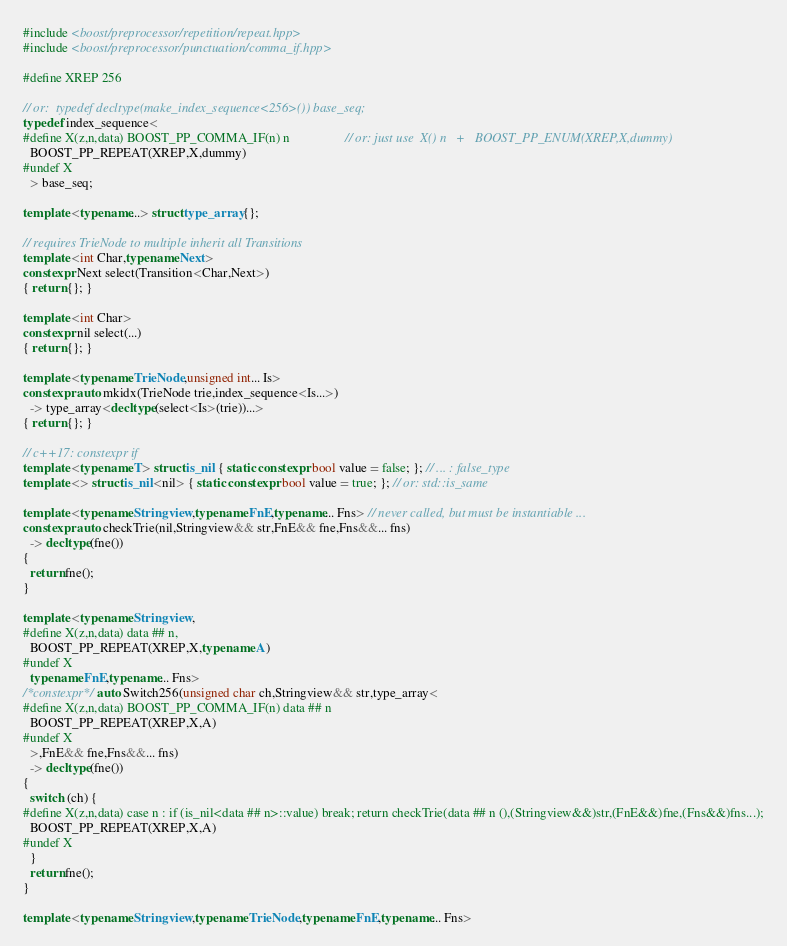<code> <loc_0><loc_0><loc_500><loc_500><_C++_>
#include <boost/preprocessor/repetition/repeat.hpp>
#include <boost/preprocessor/punctuation/comma_if.hpp>

#define XREP 256

// or:  typedef decltype(make_index_sequence<256>()) base_seq;
typedef index_sequence<
#define X(z,n,data) BOOST_PP_COMMA_IF(n) n                 // or: just use  X() n   +   BOOST_PP_ENUM(XREP,X,dummy)
  BOOST_PP_REPEAT(XREP,X,dummy)
#undef X
  > base_seq;

template <typename...> struct type_array {};

// requires TrieNode to multiple inherit all Transitions
template <int Char,typename Next>
constexpr Next select(Transition<Char,Next>)
{ return {}; }

template <int Char>
constexpr nil select(...)
{ return {}; }

template <typename TrieNode,unsigned int... Is>
constexpr auto mkidx(TrieNode trie,index_sequence<Is...>)
  -> type_array<decltype(select<Is>(trie))...>
{ return {}; }

// c++17: constexpr if
template <typename T> struct is_nil { static constexpr bool value = false; }; // ... : false_type
template <> struct is_nil<nil> { static constexpr bool value = true; }; // or: std::is_same

template <typename Stringview,typename FnE,typename... Fns> // never called, but must be instantiable ...
constexpr auto checkTrie(nil,Stringview&& str,FnE&& fne,Fns&&... fns)
  -> decltype(fne())
{
  return fne();
}

template <typename Stringview,
#define X(z,n,data) data ## n,
  BOOST_PP_REPEAT(XREP,X,typename A)
#undef X
  typename FnE,typename... Fns>
/*constexpr*/ auto Switch256(unsigned char ch,Stringview&& str,type_array<
#define X(z,n,data) BOOST_PP_COMMA_IF(n) data ## n
  BOOST_PP_REPEAT(XREP,X,A)
#undef X
  >,FnE&& fne,Fns&&... fns)
  -> decltype(fne())
{
  switch (ch) {
#define X(z,n,data) case n : if (is_nil<data ## n>::value) break; return checkTrie(data ## n (),(Stringview&&)str,(FnE&&)fne,(Fns&&)fns...);
  BOOST_PP_REPEAT(XREP,X,A)
#undef X
  }
  return fne();
}

template <typename Stringview,typename TrieNode,typename FnE,typename... Fns></code> 